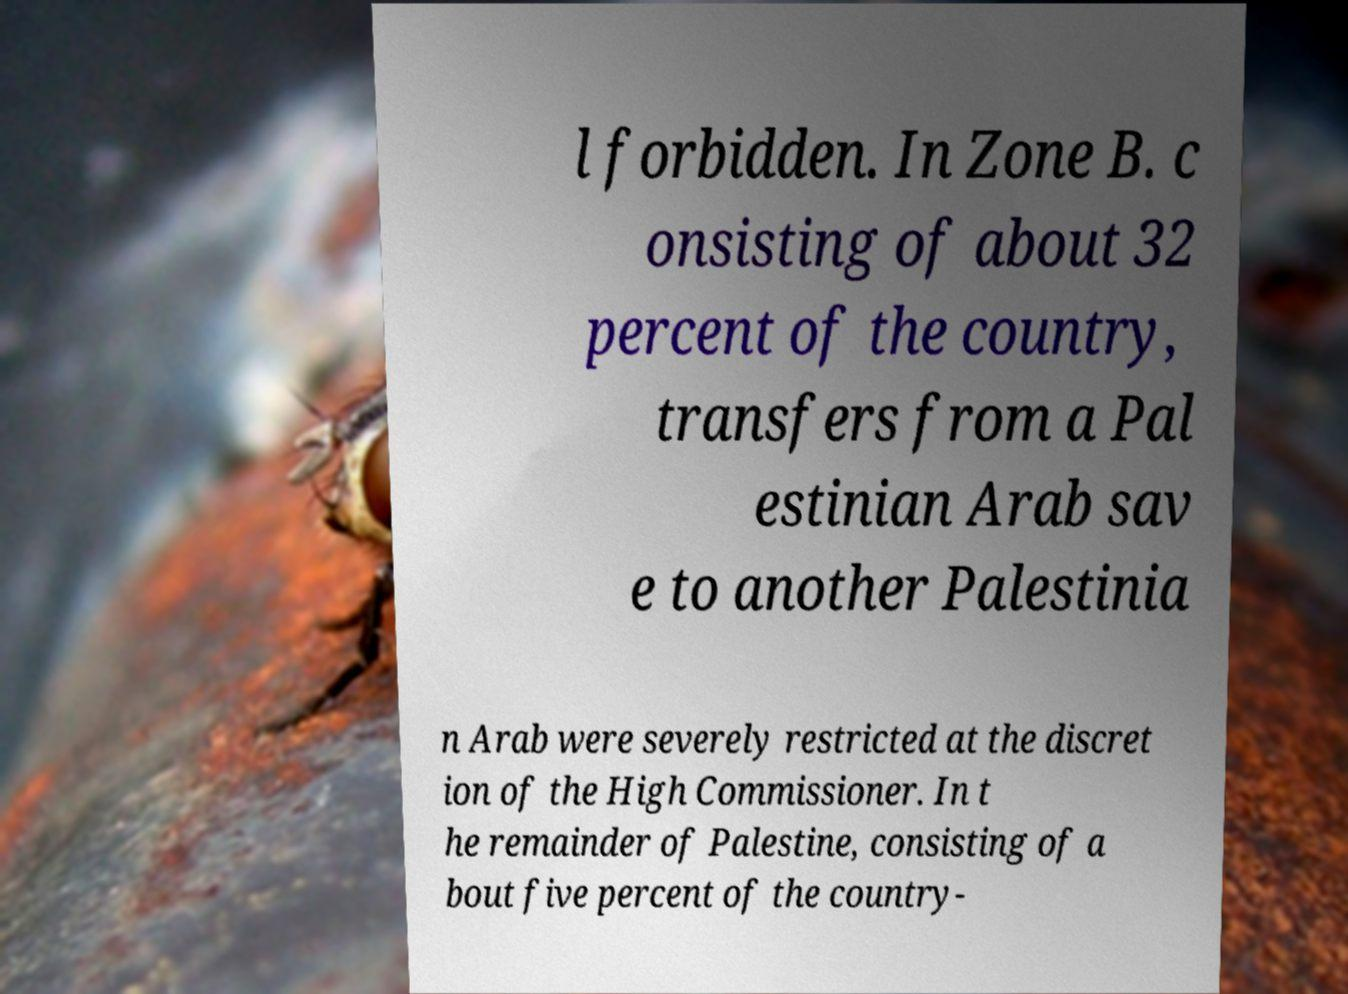There's text embedded in this image that I need extracted. Can you transcribe it verbatim? l forbidden. In Zone B. c onsisting of about 32 percent of the country, transfers from a Pal estinian Arab sav e to another Palestinia n Arab were severely restricted at the discret ion of the High Commissioner. In t he remainder of Palestine, consisting of a bout five percent of the country- 